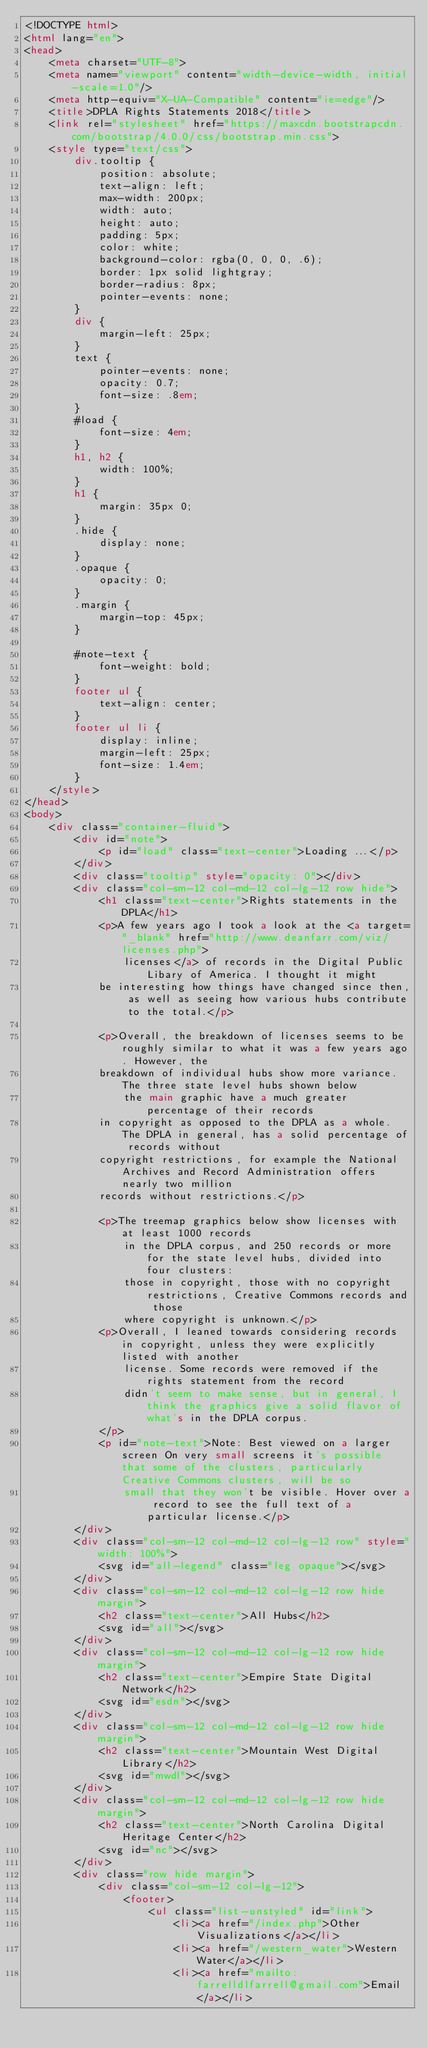<code> <loc_0><loc_0><loc_500><loc_500><_HTML_><!DOCTYPE html>
<html lang="en">
<head>
    <meta charset="UTF-8">
    <meta name="viewport" content="width-device-width, initial-scale=1.0"/>
    <meta http-equiv="X-UA-Compatible" content="ie=edge"/>
    <title>DPLA Rights Statements 2018</title>
    <link rel="stylesheet" href="https://maxcdn.bootstrapcdn.com/bootstrap/4.0.0/css/bootstrap.min.css">
    <style type="text/css">
        div.tooltip {
            position: absolute;
            text-align: left;
            max-width: 200px;
            width: auto;
            height: auto;
            padding: 5px;
            color: white;
            background-color: rgba(0, 0, 0, .6);
            border: 1px solid lightgray;
            border-radius: 8px;
            pointer-events: none;
        }
        div {
            margin-left: 25px;
        }
        text {
            pointer-events: none;
            opacity: 0.7;
            font-size: .8em;
        }
        #load {
            font-size: 4em;
        }
        h1, h2 {
            width: 100%;
        }
        h1 {
            margin: 35px 0;
        }
        .hide {
            display: none;
        }
        .opaque {
            opacity: 0;
        }
        .margin {
            margin-top: 45px;
        }

        #note-text {
            font-weight: bold;
        }
        footer ul {
            text-align: center;
        }
        footer ul li {
            display: inline;
            margin-left: 25px;
            font-size: 1.4em;
        }
    </style>
</head>
<body>
    <div class="container-fluid">
        <div id="note">
            <p id="load" class="text-center">Loading ...</p>
        </div>
        <div class="tooltip" style="opacity: 0"></div>
        <div class="col-sm-12 col-md-12 col-lg-12 row hide">
            <h1 class="text-center">Rights statements in the DPLA</h1>
            <p>A few years ago I took a look at the <a target="_blank" href="http://www.deanfarr.com/viz/licenses.php">
                licenses</a> of records in the Digital Public Libary of America. I thought it might
            be interesting how things have changed since then, as well as seeing how various hubs contribute to the total.</p>

            <p>Overall, the breakdown of licenses seems to be roughly similar to what it was a few years ago. However, the
            breakdown of individual hubs show more variance. The three state level hubs shown below
                the main graphic have a much greater percentage of their records
            in copyright as opposed to the DPLA as a whole. The DPLA in general, has a solid percentage of records without
            copyright restrictions, for example the National Archives and Record Administration offers nearly two million
            records without restrictions.</p>

            <p>The treemap graphics below show licenses with at least 1000 records
                in the DPLA corpus, and 250 records or more for the state level hubs, divided into four clusters:
                those in copyright, those with no copyright restrictions, Creative Commons records and those
                where copyright is unknown.</p>
            <p>Overall, I leaned towards considering records in copyright, unless they were explicitly listed with another
                license. Some records were removed if the rights statement from the record
                didn't seem to make sense, but in general, I think the graphics give a solid flavor of what's in the DPLA corpus.
            </p>
            <p id="note-text">Note: Best viewed on a larger screen On very small screens it's possible that some of the clusters, particularly Creative Commons clusters, will be so
                small that they won't be visible. Hover over a record to see the full text of a particular license.</p>
        </div>
        <div class="col-sm-12 col-md-12 col-lg-12 row" style="width: 100%">
            <svg id="all-legend" class="leg opaque"></svg>
        </div>
        <div class="col-sm-12 col-md-12 col-lg-12 row hide margin">
            <h2 class="text-center">All Hubs</h2>
            <svg id="all"></svg>
        </div>
        <div class="col-sm-12 col-md-12 col-lg-12 row hide margin">
            <h2 class="text-center">Empire State Digital Network</h2>
            <svg id="esdn"></svg>
        </div>
        <div class="col-sm-12 col-md-12 col-lg-12 row hide margin">
            <h2 class="text-center">Mountain West Digital Library</h2>
            <svg id="mwdl"></svg>
        </div>
        <div class="col-sm-12 col-md-12 col-lg-12 row hide margin">
            <h2 class="text-center">North Carolina Digital Heritage Center</h2>
            <svg id="nc"></svg>
        </div>
        <div class="row hide margin">
            <div class="col-sm-12 col-lg-12">
                <footer>
                    <ul class="list-unstyled" id="link">
                        <li><a href="/index.php">Other Visualizations</a></li>
                        <li><a href="/western_water">Western Water</a></li>
                        <li><a href="mailto:farrelldlfarrell@gmail.com">Email</a></li></code> 